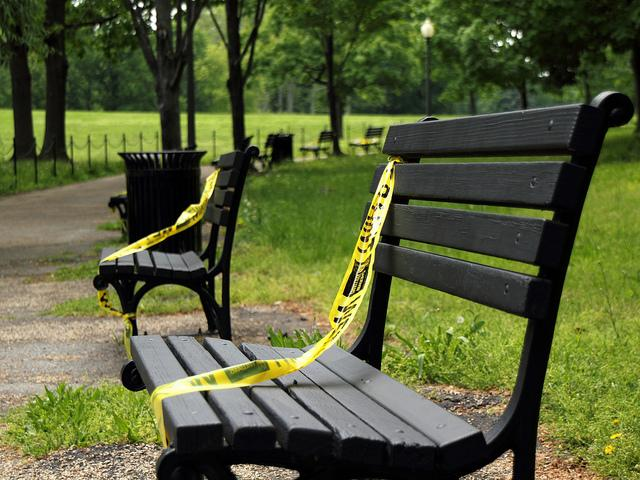For what reason were the benches likely sealed off with caution tape?

Choices:
A) rain
B) private
C) broken
D) wet paint wet paint 